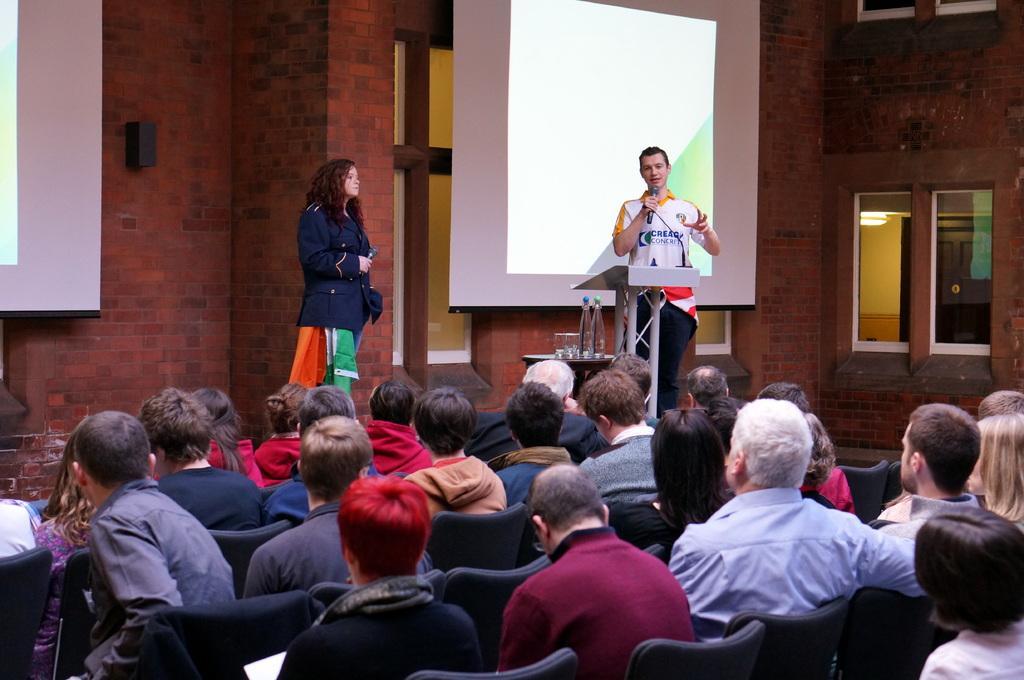Describe this image in one or two sentences. In this picture we can see a few people sitting on the chair from left to right. There is a person holding a microphone in his hand. We can see a few glasses and bottles on the table. There is a woman holding a microphone. We can see a few projects and a black object on the wall. We can see a few windows on the right side. 